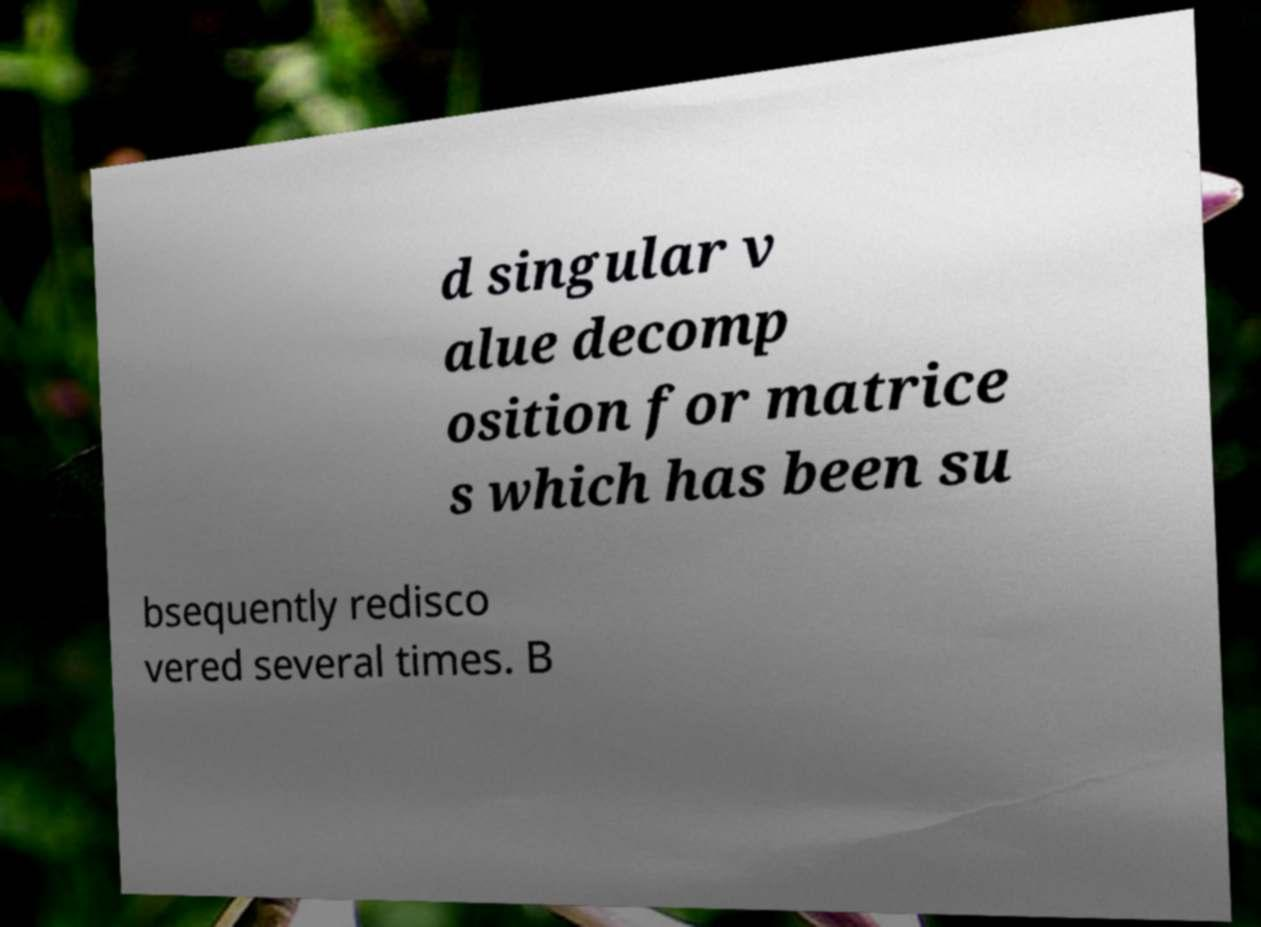Could you extract and type out the text from this image? d singular v alue decomp osition for matrice s which has been su bsequently redisco vered several times. B 